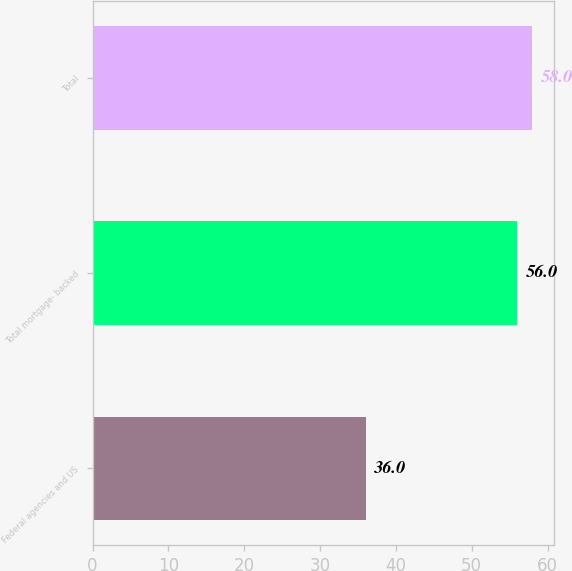Convert chart to OTSL. <chart><loc_0><loc_0><loc_500><loc_500><bar_chart><fcel>Federal agencies and US<fcel>Total mortgage- backed<fcel>Total<nl><fcel>36<fcel>56<fcel>58<nl></chart> 